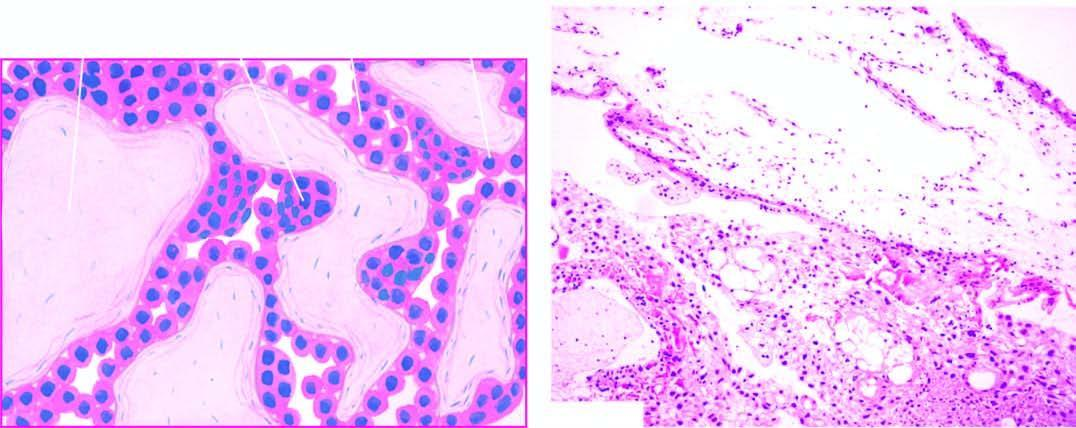s hydatidiform mole characterised by hydropic and avascular enlarged villi with trophoblastic proliferation in the form of masses and sheets?
Answer the question using a single word or phrase. Yes 